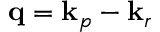<formula> <loc_0><loc_0><loc_500><loc_500>\mathbf q = \mathbf k _ { p } - \mathbf k _ { r }</formula> 